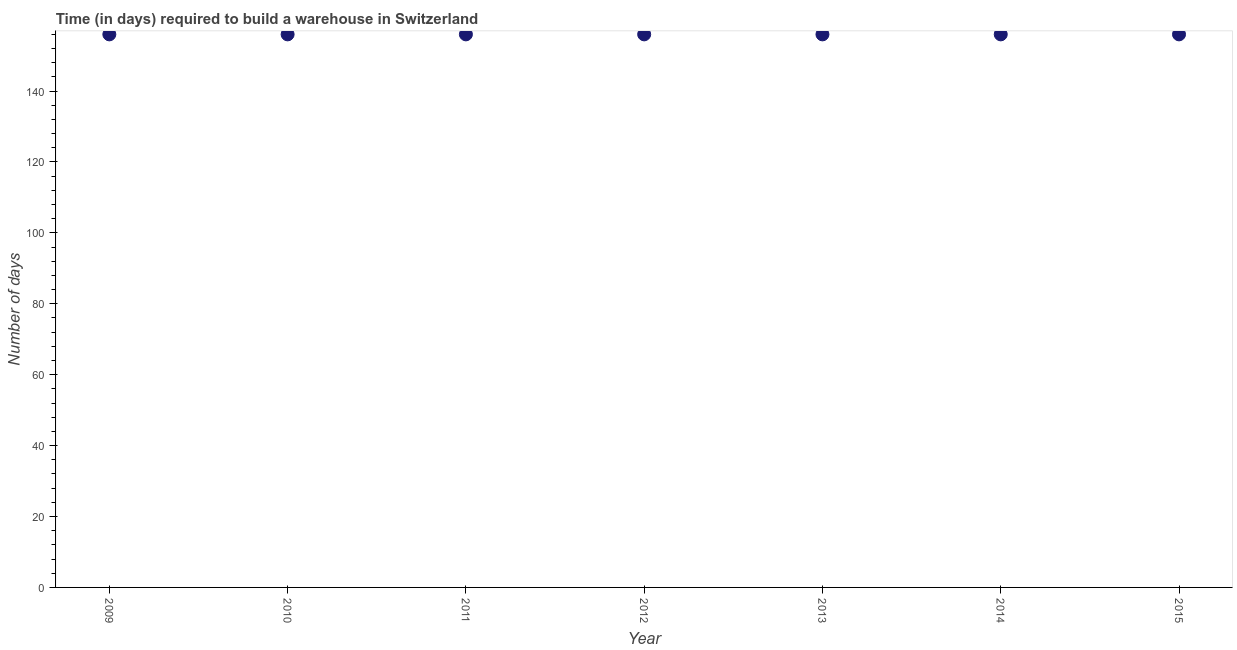What is the time required to build a warehouse in 2014?
Provide a succinct answer. 156. Across all years, what is the maximum time required to build a warehouse?
Your response must be concise. 156. Across all years, what is the minimum time required to build a warehouse?
Provide a short and direct response. 156. What is the sum of the time required to build a warehouse?
Your answer should be very brief. 1092. What is the difference between the time required to build a warehouse in 2009 and 2014?
Provide a short and direct response. 0. What is the average time required to build a warehouse per year?
Provide a succinct answer. 156. What is the median time required to build a warehouse?
Provide a short and direct response. 156. In how many years, is the time required to build a warehouse greater than 16 days?
Offer a terse response. 7. Is the time required to build a warehouse in 2009 less than that in 2014?
Ensure brevity in your answer.  No. What is the difference between the highest and the second highest time required to build a warehouse?
Provide a short and direct response. 0. What is the difference between the highest and the lowest time required to build a warehouse?
Your answer should be compact. 0. In how many years, is the time required to build a warehouse greater than the average time required to build a warehouse taken over all years?
Give a very brief answer. 0. Does the time required to build a warehouse monotonically increase over the years?
Offer a terse response. No. How many dotlines are there?
Offer a terse response. 1. Are the values on the major ticks of Y-axis written in scientific E-notation?
Give a very brief answer. No. Does the graph contain any zero values?
Keep it short and to the point. No. What is the title of the graph?
Offer a very short reply. Time (in days) required to build a warehouse in Switzerland. What is the label or title of the Y-axis?
Ensure brevity in your answer.  Number of days. What is the Number of days in 2009?
Make the answer very short. 156. What is the Number of days in 2010?
Ensure brevity in your answer.  156. What is the Number of days in 2011?
Ensure brevity in your answer.  156. What is the Number of days in 2012?
Provide a short and direct response. 156. What is the Number of days in 2013?
Your answer should be very brief. 156. What is the Number of days in 2014?
Your answer should be very brief. 156. What is the Number of days in 2015?
Offer a terse response. 156. What is the difference between the Number of days in 2009 and 2014?
Your response must be concise. 0. What is the difference between the Number of days in 2009 and 2015?
Offer a very short reply. 0. What is the difference between the Number of days in 2010 and 2012?
Make the answer very short. 0. What is the difference between the Number of days in 2010 and 2014?
Make the answer very short. 0. What is the difference between the Number of days in 2011 and 2015?
Ensure brevity in your answer.  0. What is the difference between the Number of days in 2012 and 2014?
Your answer should be compact. 0. What is the difference between the Number of days in 2012 and 2015?
Your response must be concise. 0. What is the difference between the Number of days in 2013 and 2014?
Your answer should be very brief. 0. What is the difference between the Number of days in 2013 and 2015?
Offer a terse response. 0. What is the difference between the Number of days in 2014 and 2015?
Your answer should be compact. 0. What is the ratio of the Number of days in 2009 to that in 2013?
Give a very brief answer. 1. What is the ratio of the Number of days in 2009 to that in 2014?
Make the answer very short. 1. What is the ratio of the Number of days in 2009 to that in 2015?
Offer a terse response. 1. What is the ratio of the Number of days in 2010 to that in 2013?
Make the answer very short. 1. What is the ratio of the Number of days in 2010 to that in 2015?
Your answer should be compact. 1. What is the ratio of the Number of days in 2011 to that in 2012?
Your answer should be very brief. 1. What is the ratio of the Number of days in 2011 to that in 2013?
Make the answer very short. 1. What is the ratio of the Number of days in 2012 to that in 2013?
Your answer should be very brief. 1. What is the ratio of the Number of days in 2012 to that in 2015?
Make the answer very short. 1. What is the ratio of the Number of days in 2013 to that in 2015?
Provide a short and direct response. 1. What is the ratio of the Number of days in 2014 to that in 2015?
Your answer should be very brief. 1. 